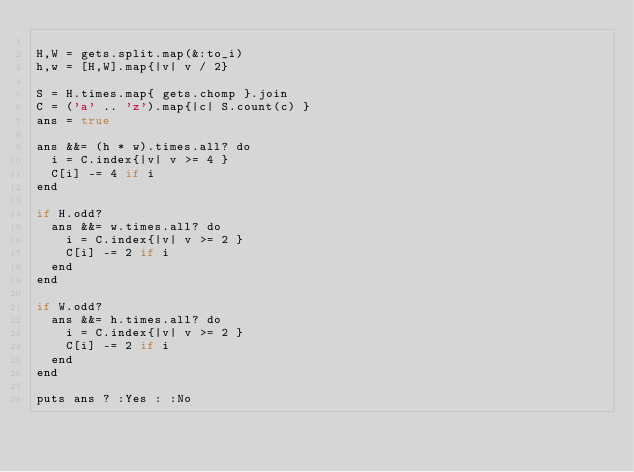Convert code to text. <code><loc_0><loc_0><loc_500><loc_500><_Rust_>
H,W = gets.split.map(&:to_i)
h,w = [H,W].map{|v| v / 2}

S = H.times.map{ gets.chomp }.join
C = ('a' .. 'z').map{|c| S.count(c) }
ans = true

ans &&= (h * w).times.all? do
  i = C.index{|v| v >= 4 }
  C[i] -= 4 if i
end

if H.odd?
  ans &&= w.times.all? do
    i = C.index{|v| v >= 2 }
    C[i] -= 2 if i
  end
end

if W.odd?
  ans &&= h.times.all? do
    i = C.index{|v| v >= 2 }
    C[i] -= 2 if i
  end
end

puts ans ? :Yes : :No
</code> 